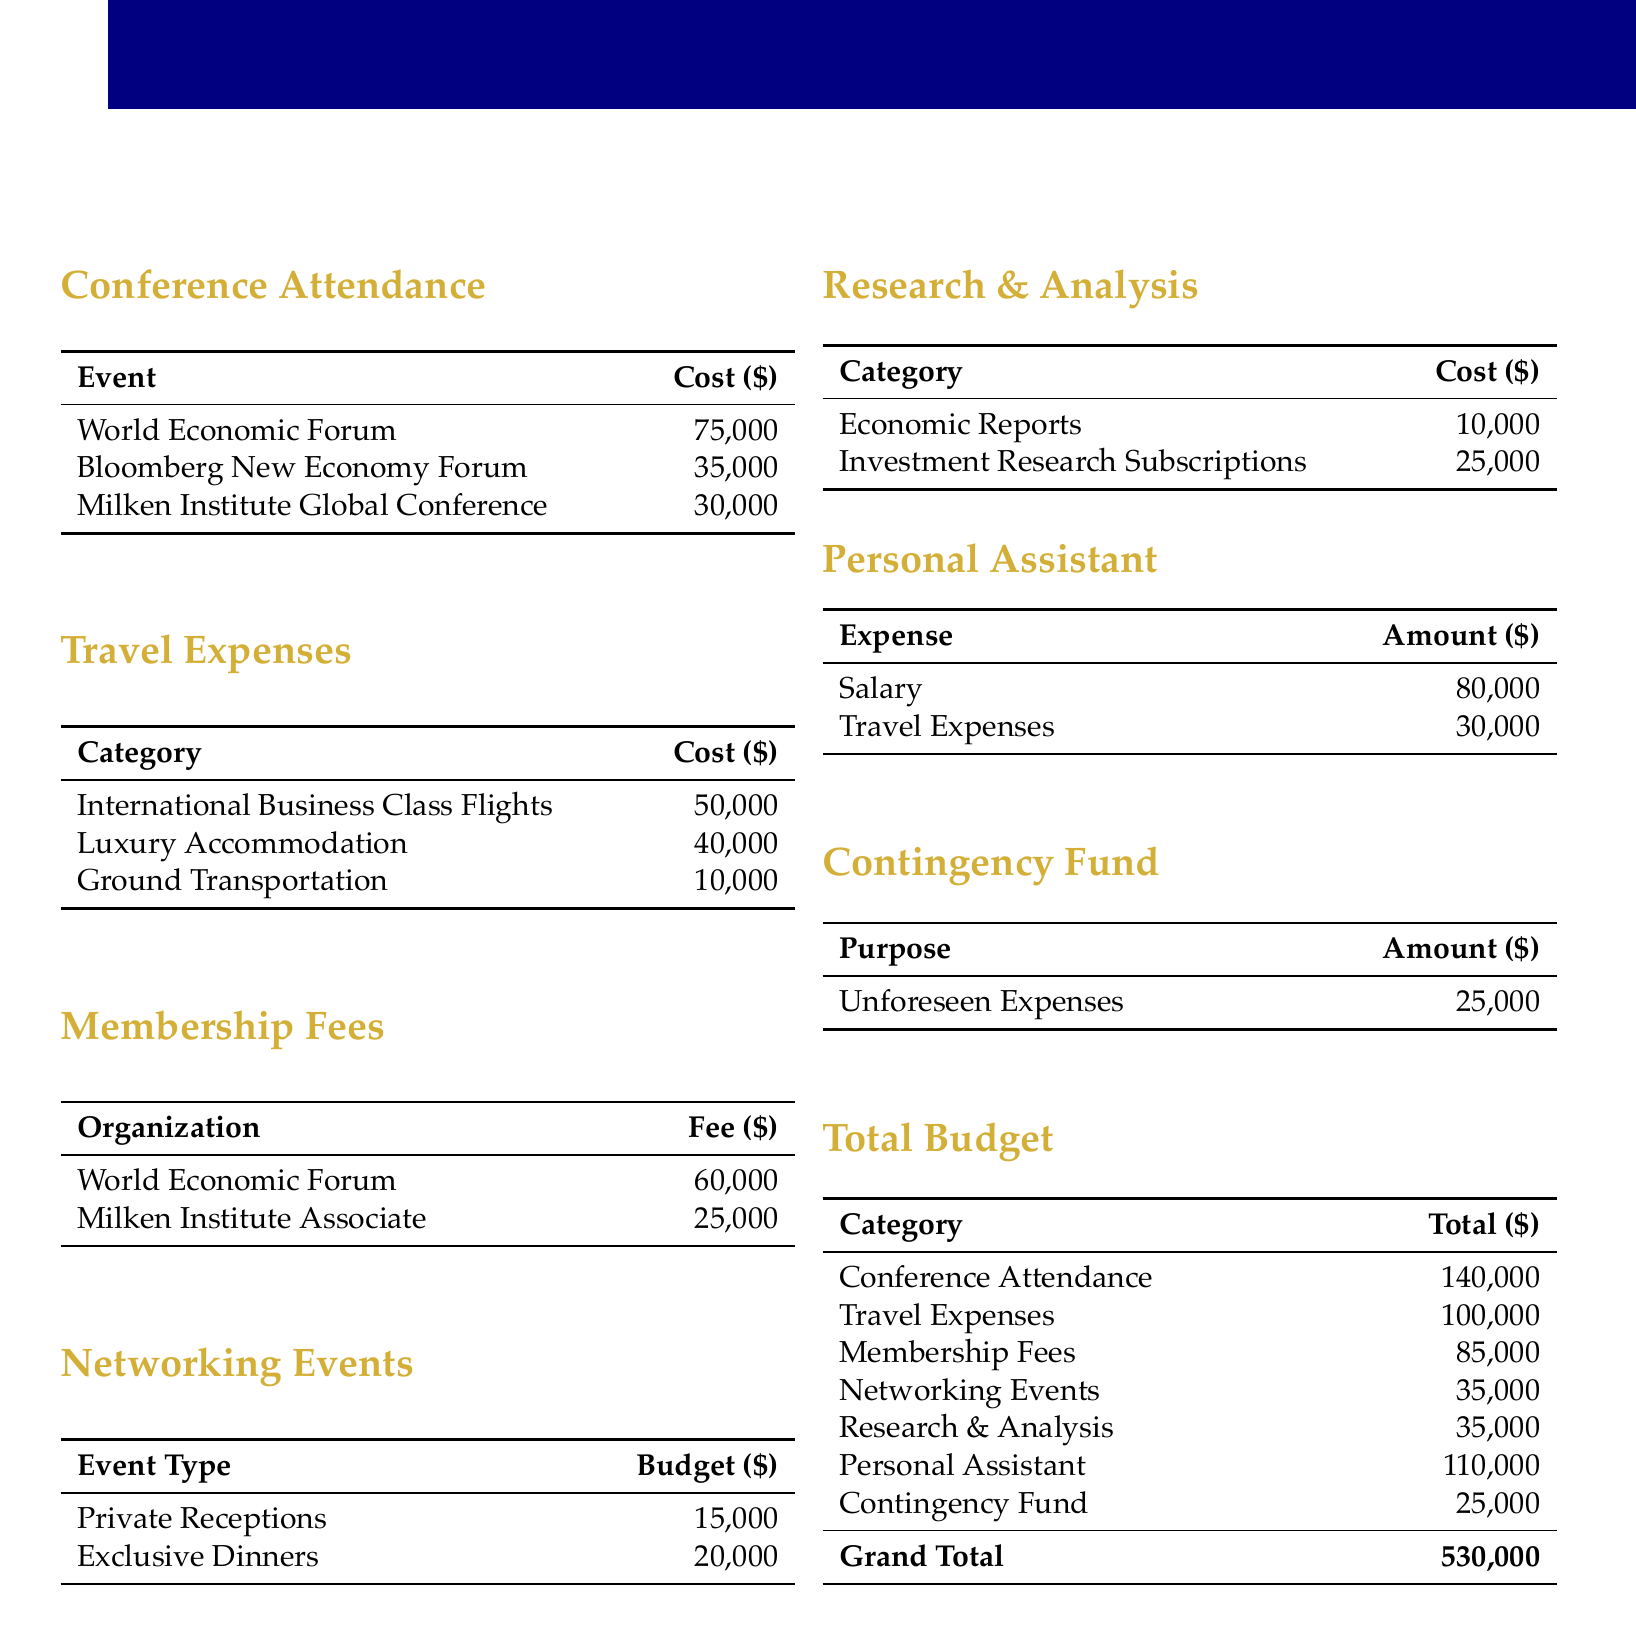What is the total budget for attending global economic forums? The grand total for the budget document is the sum of all costs listed, which adds up to $530,000.
Answer: $530,000 How much is allocated for travel expenses? The document specifies $100,000 under travel expenses.
Answer: $100,000 What is the membership fee for the World Economic Forum? The document states that the membership fee for the World Economic Forum is $60,000.
Answer: $60,000 What is the cost for private receptions under networking events? The budget for private receptions is explicitly listed as $15,000 in the document.
Answer: $15,000 How much is budgeted for personal assistant's salary? The salary for the personal assistant is mentioned as $80,000 in the budget.
Answer: $80,000 What is the total amount allocated for economic reports and investment research subscriptions combined? By adding the costs together, the total for these categories amounts to $35,000, which is derived from $10,000 for economic reports and $25,000 for investment research subscriptions.
Answer: $35,000 What percentage of the total budget is allocated to conference attendance? The budget for conference attendance is $140,000, which is roughly 26.4% of the total budget.
Answer: 26.4% How much is set aside for unforeseen expenses in the contingency fund? The amount allocated for unforeseen expenses in the contingency fund is $25,000 as stated in the document.
Answer: $25,000 What is the cost of luxury accommodation in travel expenses? The document lists the cost of luxury accommodation at $40,000.
Answer: $40,000 